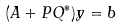Convert formula to latex. <formula><loc_0><loc_0><loc_500><loc_500>( A + P Q ^ { * } ) y = b</formula> 